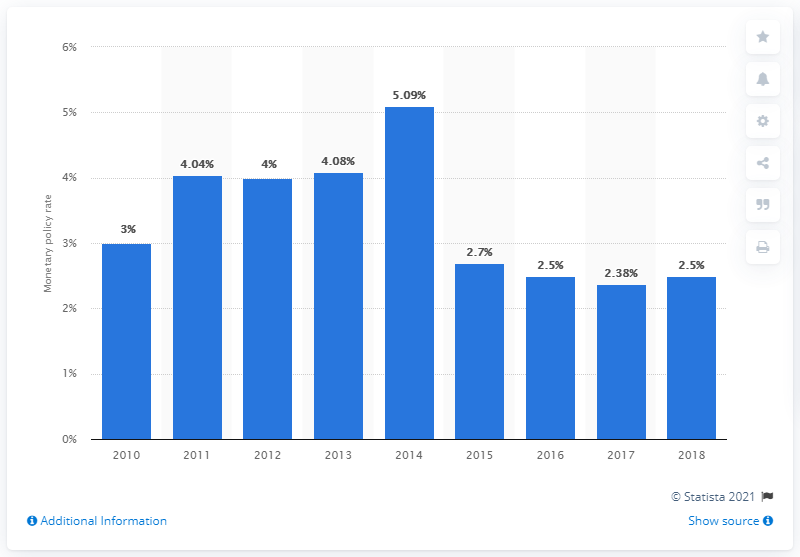Mention a couple of crucial points in this snapshot. In 2018, the monetary policy rate of the Bolivian Central Bank was 2.5%. 